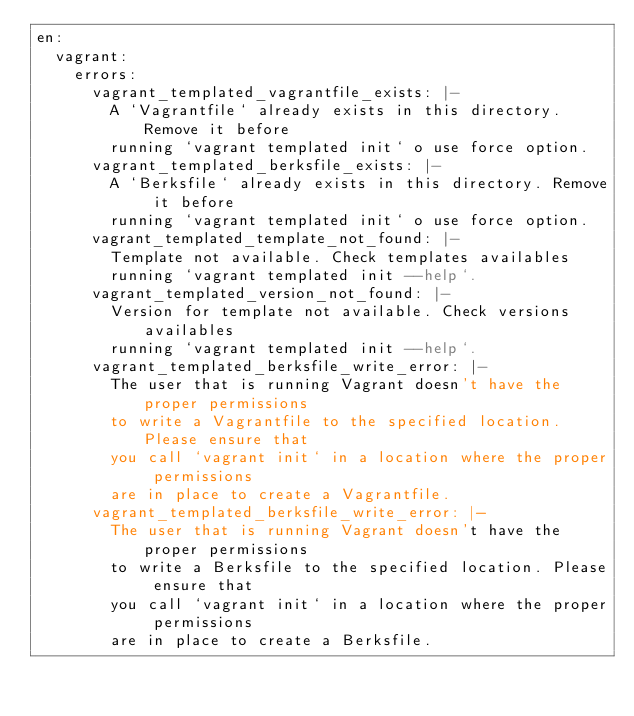Convert code to text. <code><loc_0><loc_0><loc_500><loc_500><_YAML_>en:
  vagrant:
    errors:
      vagrant_templated_vagrantfile_exists: |-
        A `Vagrantfile` already exists in this directory. Remove it before
        running `vagrant templated init` o use force option.
      vagrant_templated_berksfile_exists: |-
        A `Berksfile` already exists in this directory. Remove it before
        running `vagrant templated init` o use force option.
      vagrant_templated_template_not_found: |-
        Template not available. Check templates availables
        running `vagrant templated init --help`.
      vagrant_templated_version_not_found: |-
        Version for template not available. Check versions availables
        running `vagrant templated init --help`.
      vagrant_templated_berksfile_write_error: |-
        The user that is running Vagrant doesn't have the proper permissions
        to write a Vagrantfile to the specified location. Please ensure that
        you call `vagrant init` in a location where the proper permissions
        are in place to create a Vagrantfile.
      vagrant_templated_berksfile_write_error: |-
        The user that is running Vagrant doesn't have the proper permissions
        to write a Berksfile to the specified location. Please ensure that
        you call `vagrant init` in a location where the proper permissions
        are in place to create a Berksfile.
</code> 